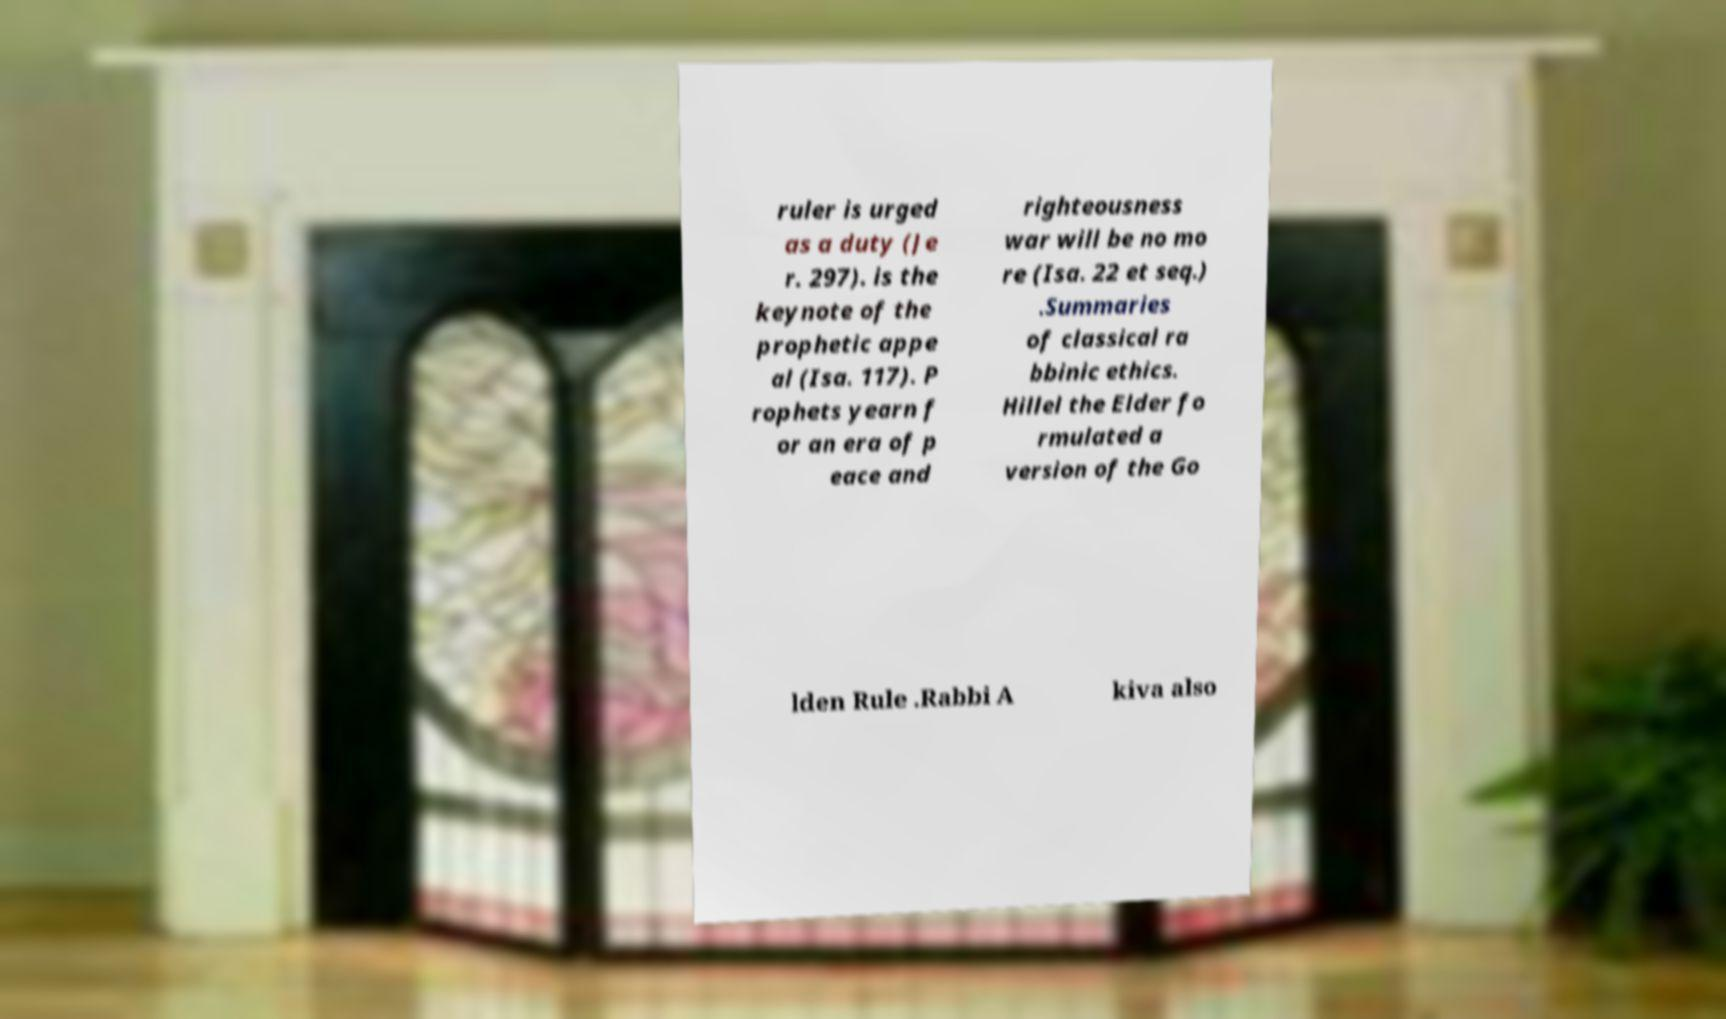I need the written content from this picture converted into text. Can you do that? ruler is urged as a duty (Je r. 297). is the keynote of the prophetic appe al (Isa. 117). P rophets yearn f or an era of p eace and righteousness war will be no mo re (Isa. 22 et seq.) .Summaries of classical ra bbinic ethics. Hillel the Elder fo rmulated a version of the Go lden Rule .Rabbi A kiva also 